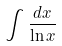<formula> <loc_0><loc_0><loc_500><loc_500>\int \frac { d x } { \ln x }</formula> 